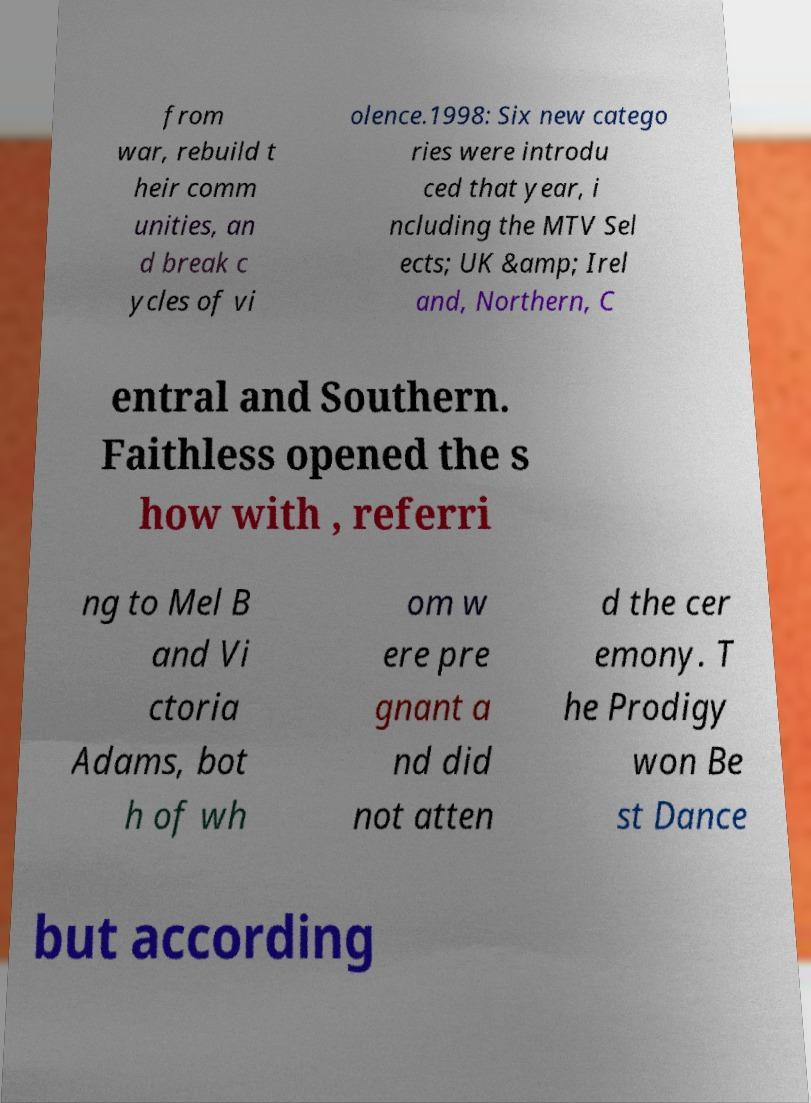For documentation purposes, I need the text within this image transcribed. Could you provide that? from war, rebuild t heir comm unities, an d break c ycles of vi olence.1998: Six new catego ries were introdu ced that year, i ncluding the MTV Sel ects; UK &amp; Irel and, Northern, C entral and Southern. Faithless opened the s how with , referri ng to Mel B and Vi ctoria Adams, bot h of wh om w ere pre gnant a nd did not atten d the cer emony. T he Prodigy won Be st Dance but according 